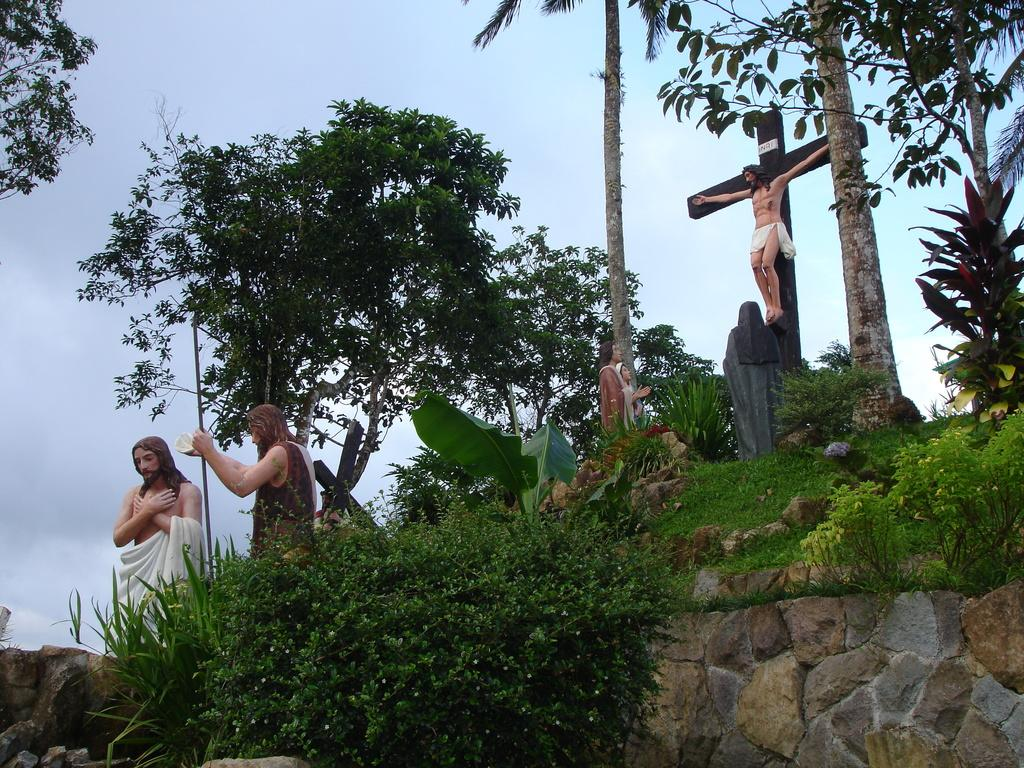What type of natural environment is present in the image? There is greenery in the image. What can be found within the greenery? There are sculptures of Jesus in the greenery. What is visible in the background of the image? The sky is visible in the background of the image. Where is the dock located in the image? There is no dock present in the image. What type of punishment is being depicted in the image? There is no punishment being depicted in the image; it features sculptures of Jesus in greenery with a visible sky in the background. 